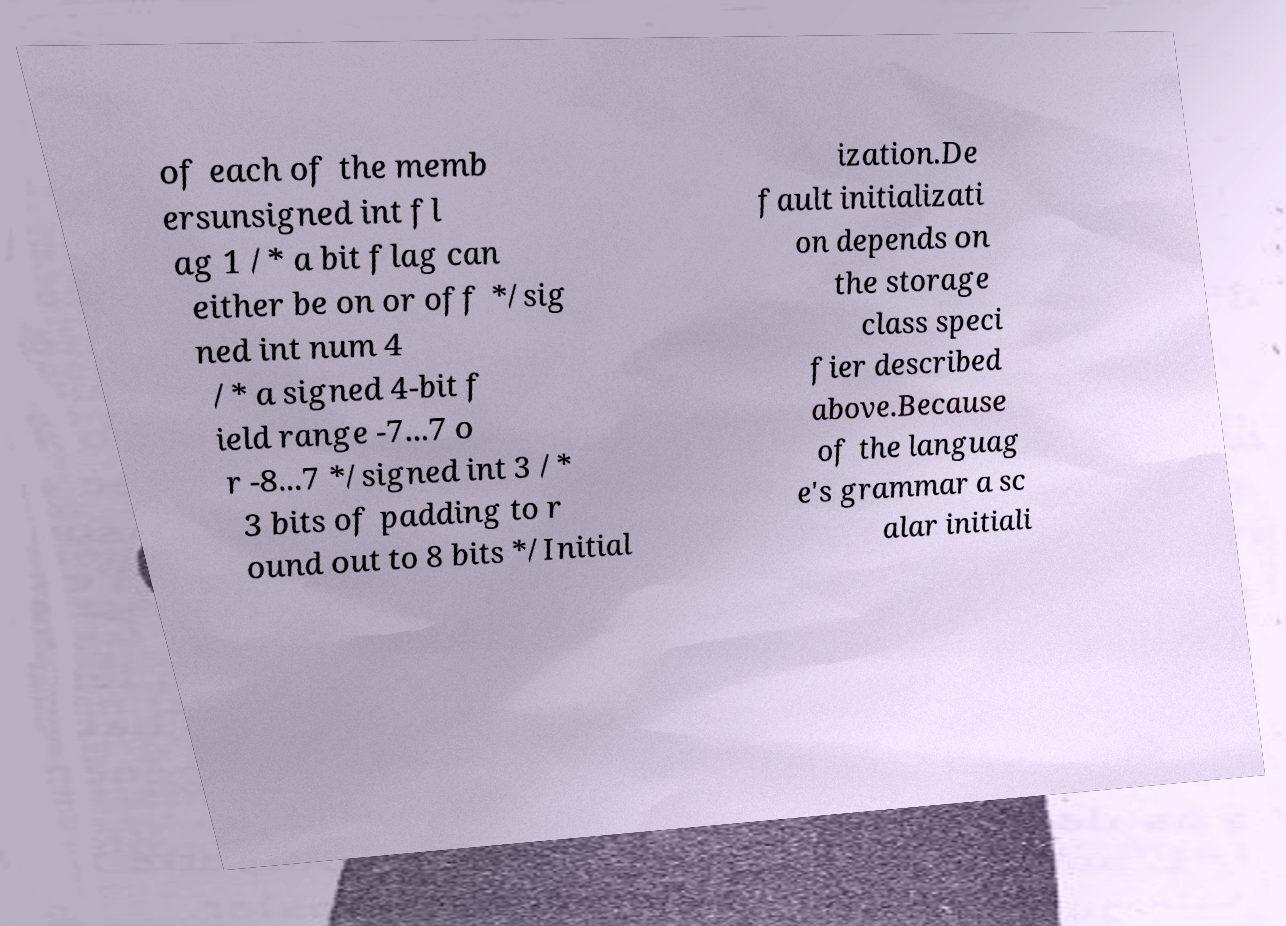Could you extract and type out the text from this image? of each of the memb ersunsigned int fl ag 1 /* a bit flag can either be on or off */sig ned int num 4 /* a signed 4-bit f ield range -7...7 o r -8...7 */signed int 3 /* 3 bits of padding to r ound out to 8 bits */Initial ization.De fault initializati on depends on the storage class speci fier described above.Because of the languag e's grammar a sc alar initiali 